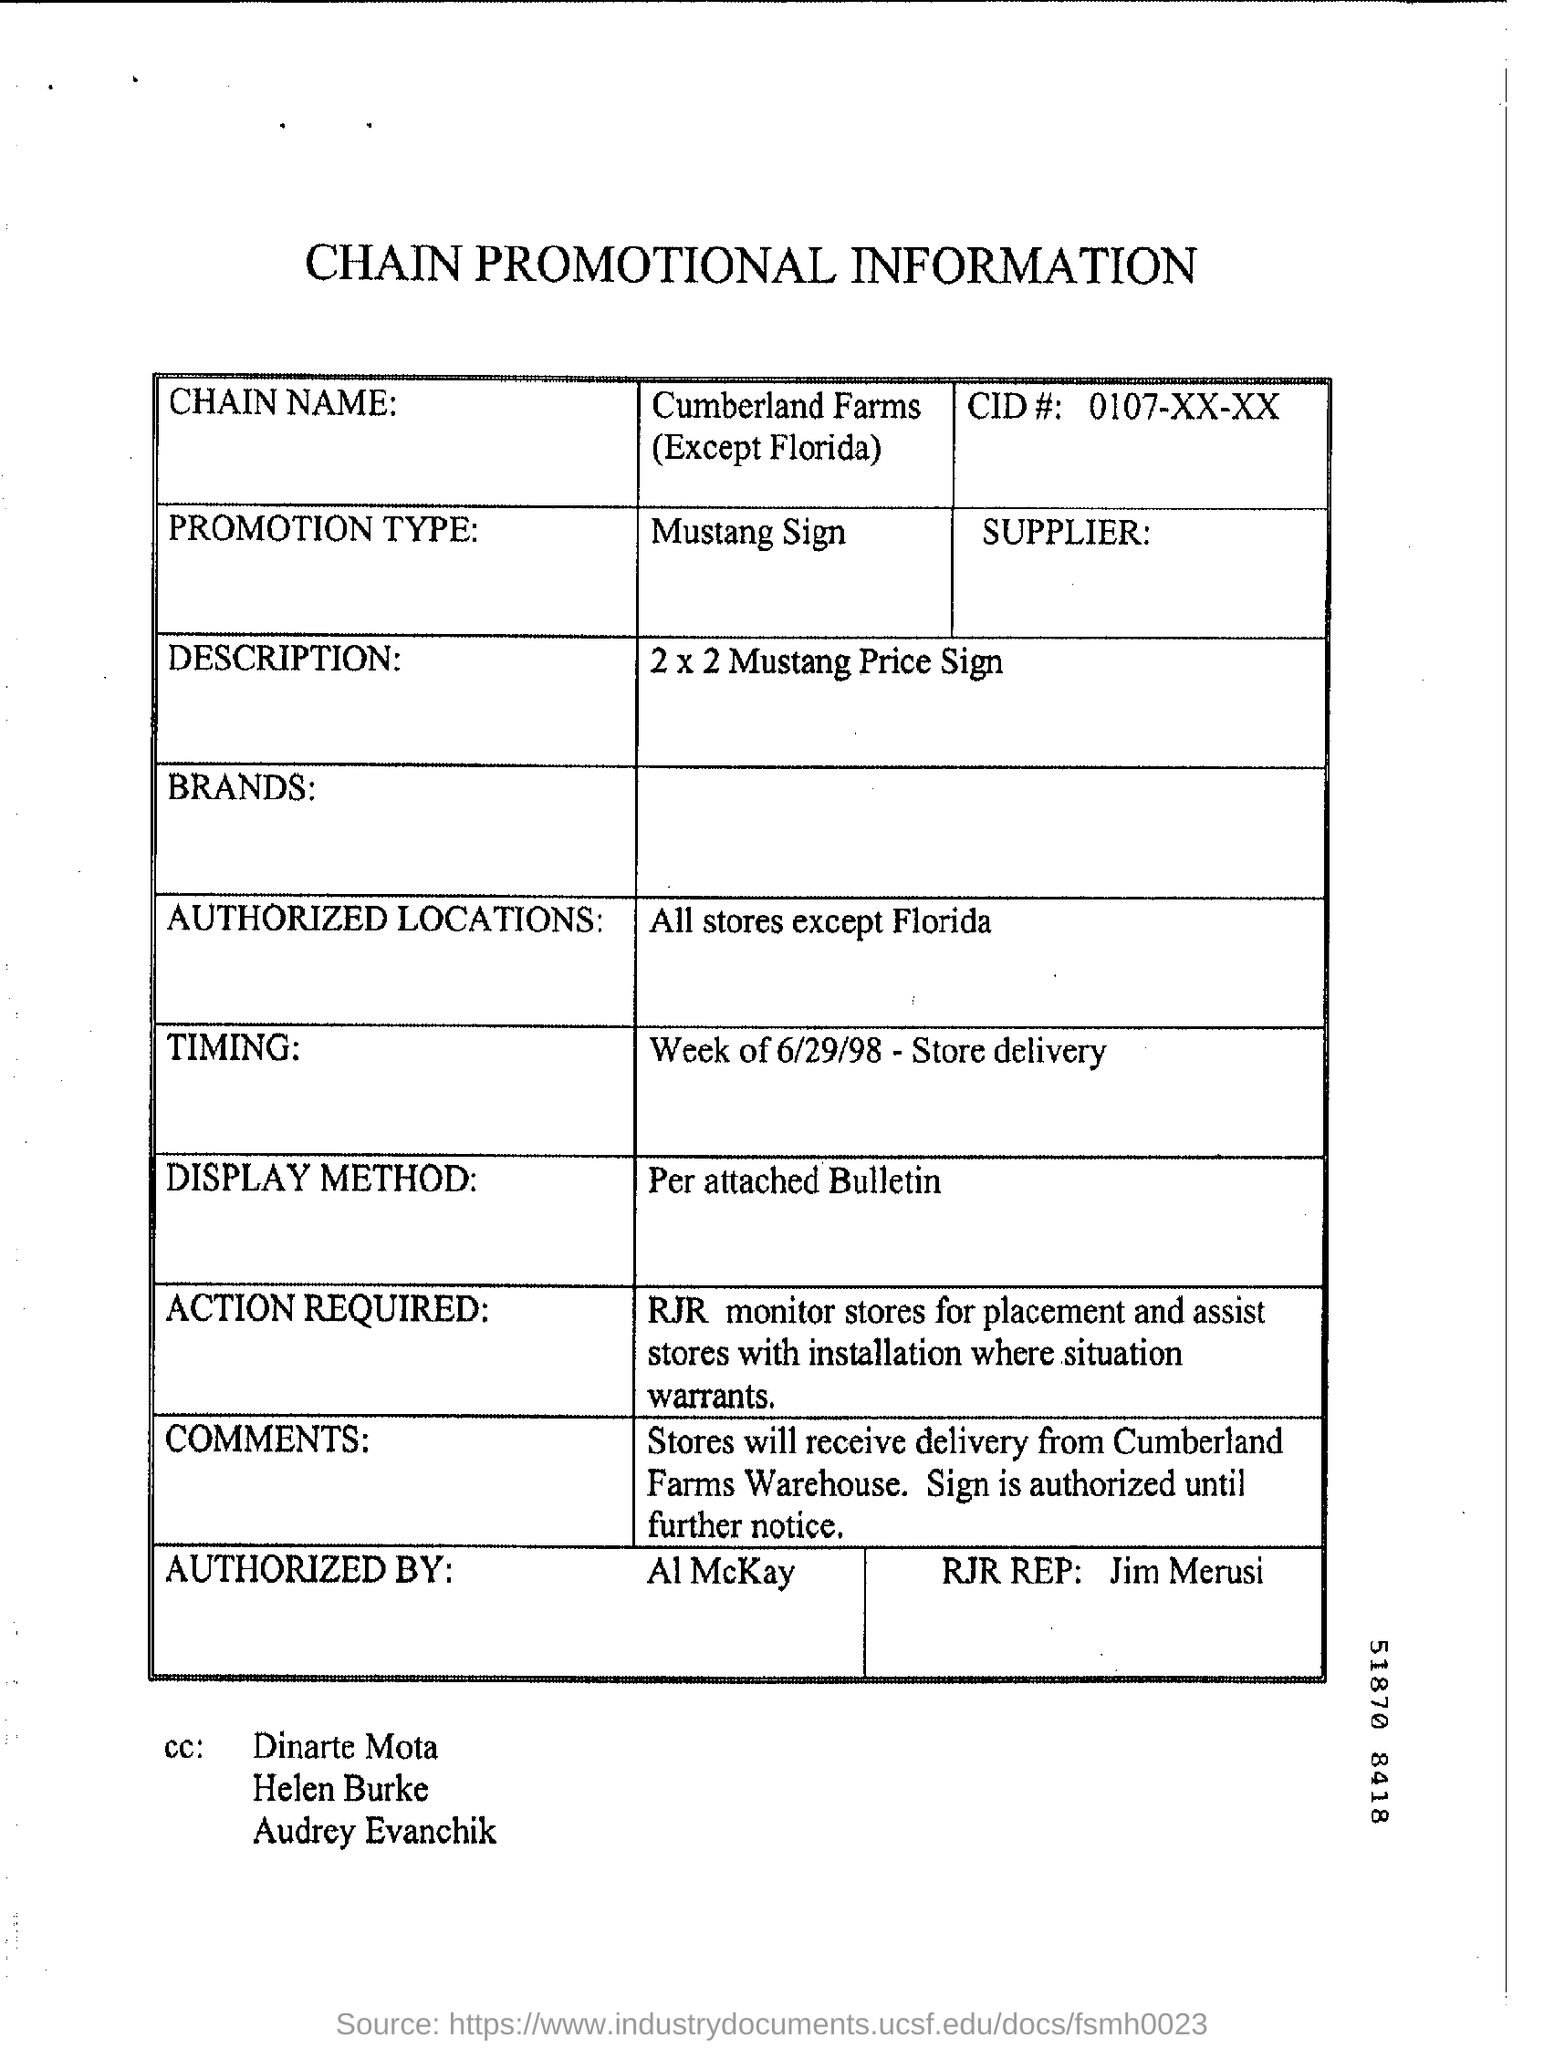Highlight a few significant elements in this photo. The CID# is 0107-XX-XX... The Mustang Price Sign is a 2 x 2 advertisement featuring the question 'What is the description?' The promotion type is Mustang Signs. The display method, as per the attached bulletin, is [insert description]. The chain name is CUMBERLAND FARMS, with the exception of Florida. 